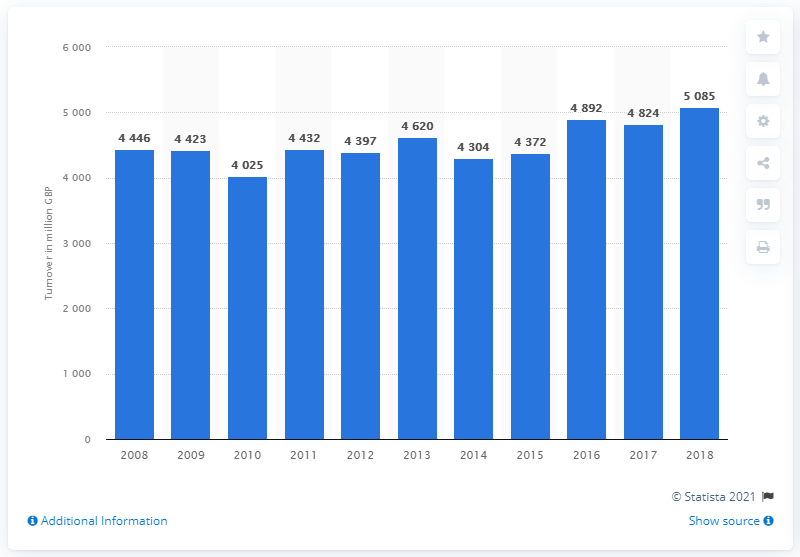Outline some significant characteristics in this image. In 2018, the turnover from retail sales of stationery and drawing materials was 5085. 